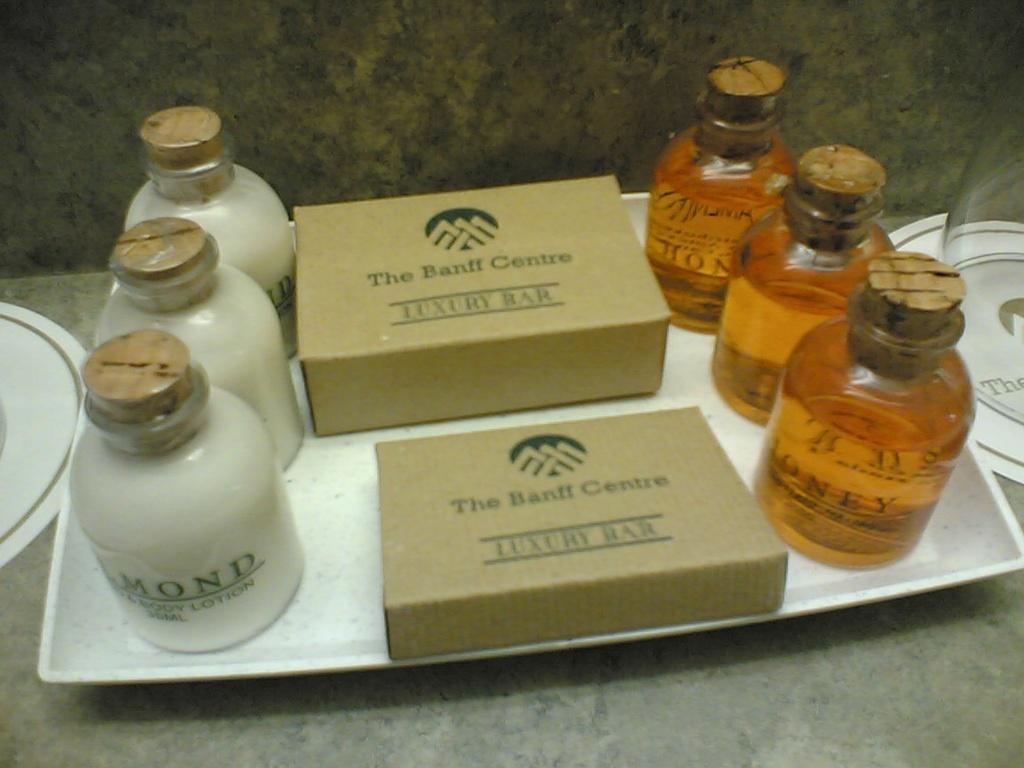What is in the boxes?
Give a very brief answer. Luxury bar. What is in the bottles on the right?
Provide a succinct answer. Honey. 